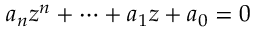<formula> <loc_0><loc_0><loc_500><loc_500>a _ { n } z ^ { n } + \dots b + a _ { 1 } z + a _ { 0 } = 0</formula> 